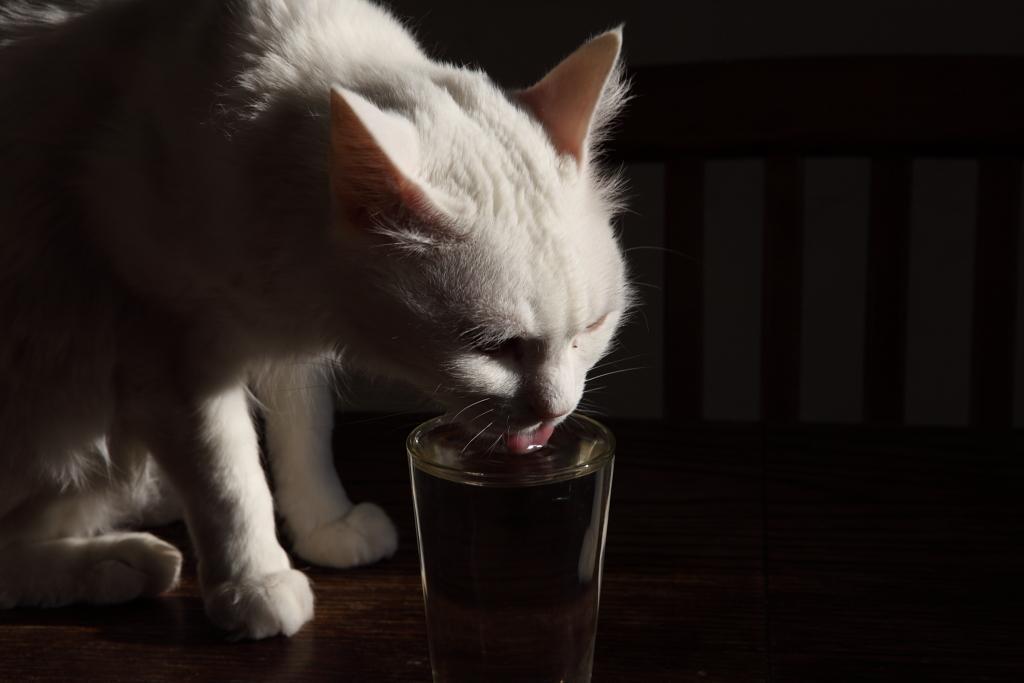Please provide a concise description of this image. In the center of the image there is a cat drinking water in a glass. At the bottom of the image there is a wooden flooring. 